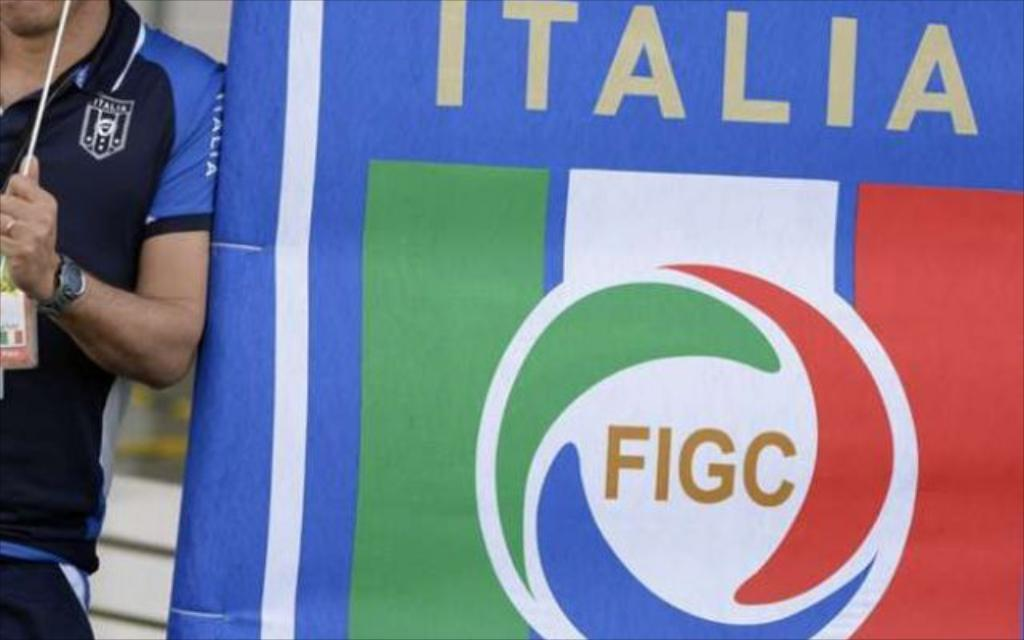Provide a one-sentence caption for the provided image. An Italia banner bears a FICG logo in the center. 